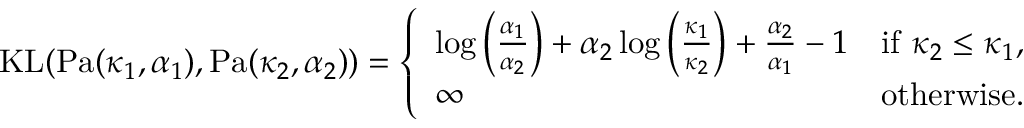<formula> <loc_0><loc_0><loc_500><loc_500>\begin{array} { r } { K L ( P a ( \kappa _ { 1 } , \alpha _ { 1 } ) , P a ( \kappa _ { 2 } , \alpha _ { 2 } ) ) = \left \{ \begin{array} { l l } { \log \left ( \frac { \alpha _ { 1 } } { \alpha _ { 2 } } \right ) + \alpha _ { 2 } \log \left ( \frac { \kappa _ { 1 } } { \kappa _ { 2 } } \right ) + \frac { \alpha _ { 2 } } { \alpha _ { 1 } } - 1 } & { i f \kappa _ { 2 } \leq \kappa _ { 1 } , } \\ { \infty } & { o t h e r w i s e . } \end{array} } \end{array}</formula> 